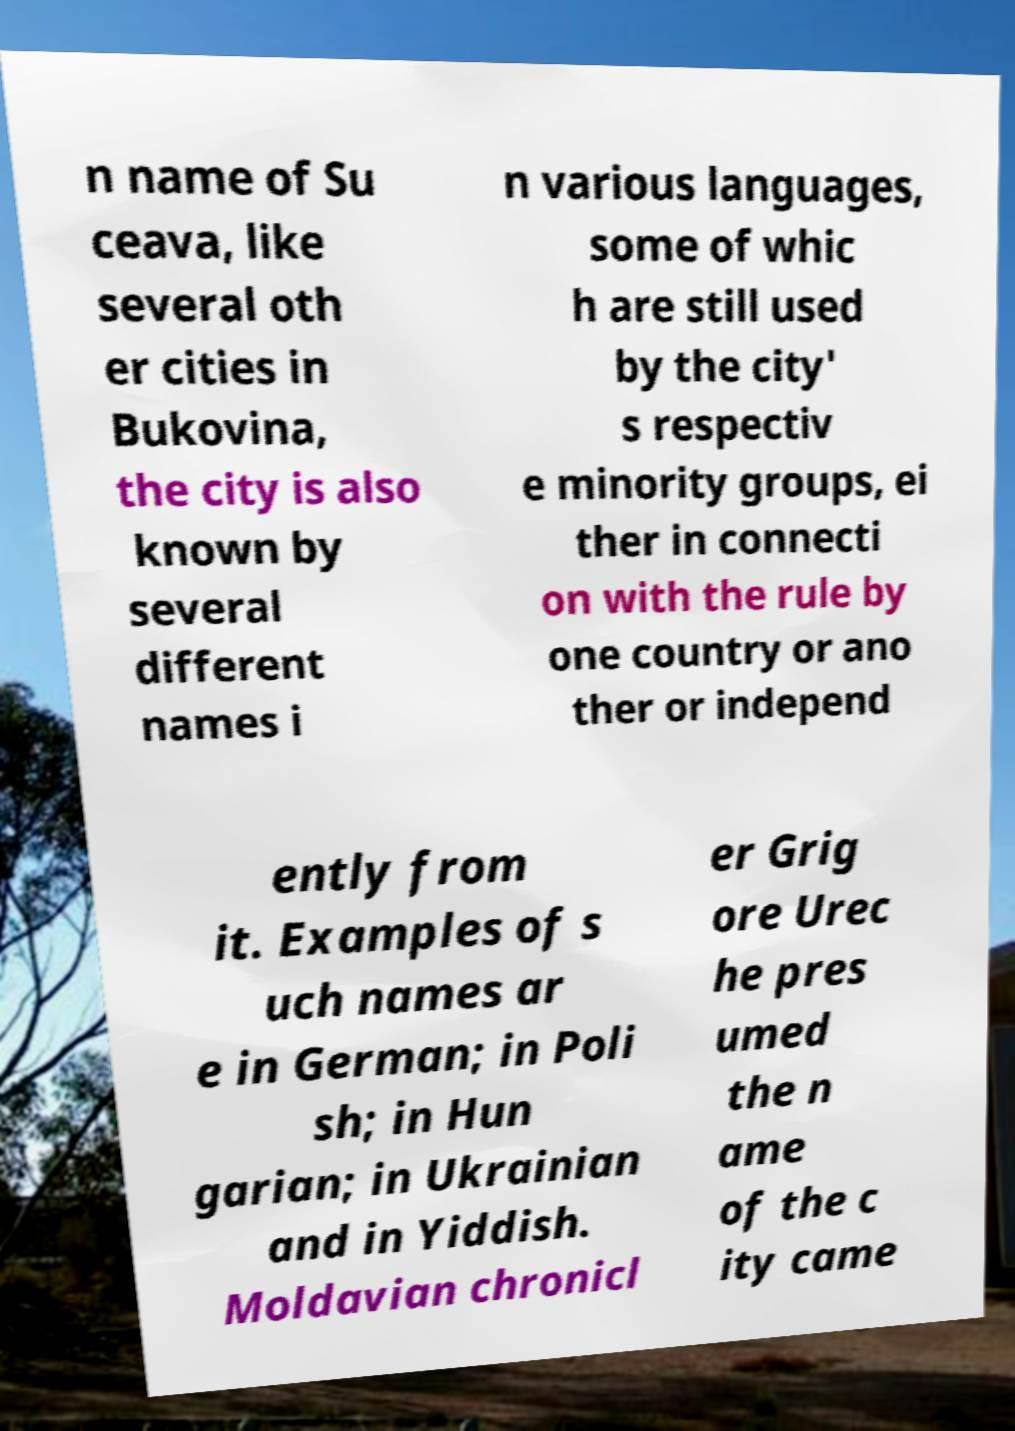Can you accurately transcribe the text from the provided image for me? n name of Su ceava, like several oth er cities in Bukovina, the city is also known by several different names i n various languages, some of whic h are still used by the city' s respectiv e minority groups, ei ther in connecti on with the rule by one country or ano ther or independ ently from it. Examples of s uch names ar e in German; in Poli sh; in Hun garian; in Ukrainian and in Yiddish. Moldavian chronicl er Grig ore Urec he pres umed the n ame of the c ity came 